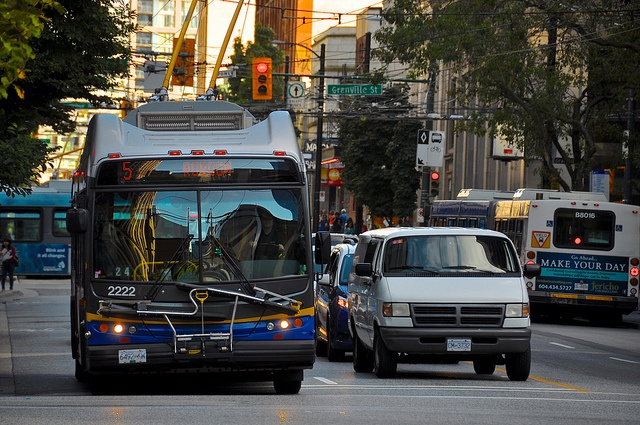Describe the objects in this image and their specific colors. I can see bus in black, gray, and darkgray tones, truck in black, gray, lightgray, and darkgray tones, car in black, gray, lightgray, and darkgray tones, bus in black, gray, and teal tones, and bus in black, navy, blue, and teal tones in this image. 